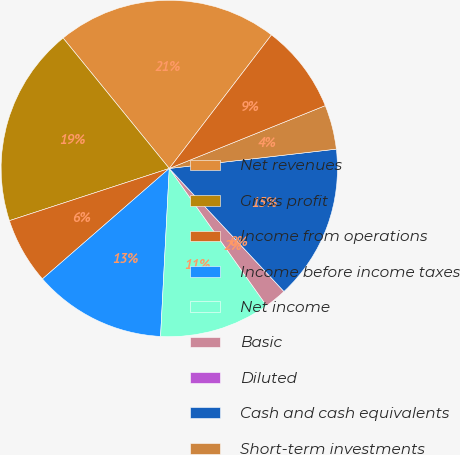Convert chart to OTSL. <chart><loc_0><loc_0><loc_500><loc_500><pie_chart><fcel>Net revenues<fcel>Gross profit<fcel>Income from operations<fcel>Income before income taxes<fcel>Net income<fcel>Basic<fcel>Diluted<fcel>Cash and cash equivalents<fcel>Short-term investments<fcel>Long-term investments<nl><fcel>21.27%<fcel>19.15%<fcel>6.38%<fcel>12.77%<fcel>10.64%<fcel>2.13%<fcel>0.0%<fcel>14.89%<fcel>4.26%<fcel>8.51%<nl></chart> 